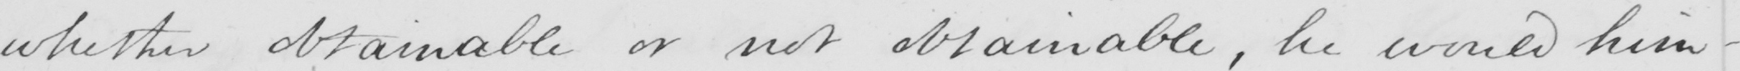Can you read and transcribe this handwriting? whether obtainable or not obtainable , he would him- 